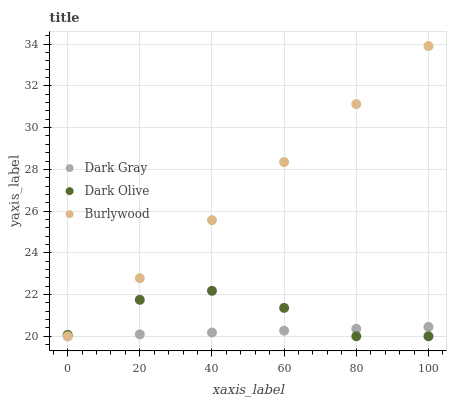Does Dark Gray have the minimum area under the curve?
Answer yes or no. Yes. Does Burlywood have the maximum area under the curve?
Answer yes or no. Yes. Does Dark Olive have the minimum area under the curve?
Answer yes or no. No. Does Dark Olive have the maximum area under the curve?
Answer yes or no. No. Is Dark Gray the smoothest?
Answer yes or no. Yes. Is Dark Olive the roughest?
Answer yes or no. Yes. Is Burlywood the smoothest?
Answer yes or no. No. Is Burlywood the roughest?
Answer yes or no. No. Does Dark Gray have the lowest value?
Answer yes or no. Yes. Does Burlywood have the highest value?
Answer yes or no. Yes. Does Dark Olive have the highest value?
Answer yes or no. No. Does Burlywood intersect Dark Olive?
Answer yes or no. Yes. Is Burlywood less than Dark Olive?
Answer yes or no. No. Is Burlywood greater than Dark Olive?
Answer yes or no. No. 